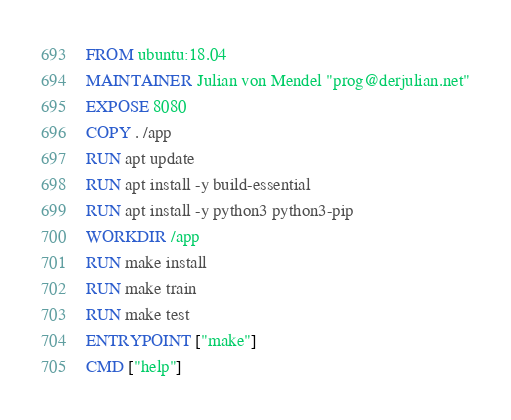Convert code to text. <code><loc_0><loc_0><loc_500><loc_500><_Dockerfile_>FROM ubuntu:18.04
MAINTAINER Julian von Mendel "prog@derjulian.net"
EXPOSE 8080
COPY . /app
RUN apt update
RUN apt install -y build-essential
RUN apt install -y python3 python3-pip
WORKDIR /app
RUN make install
RUN make train
RUN make test
ENTRYPOINT ["make"]
CMD ["help"]
</code> 